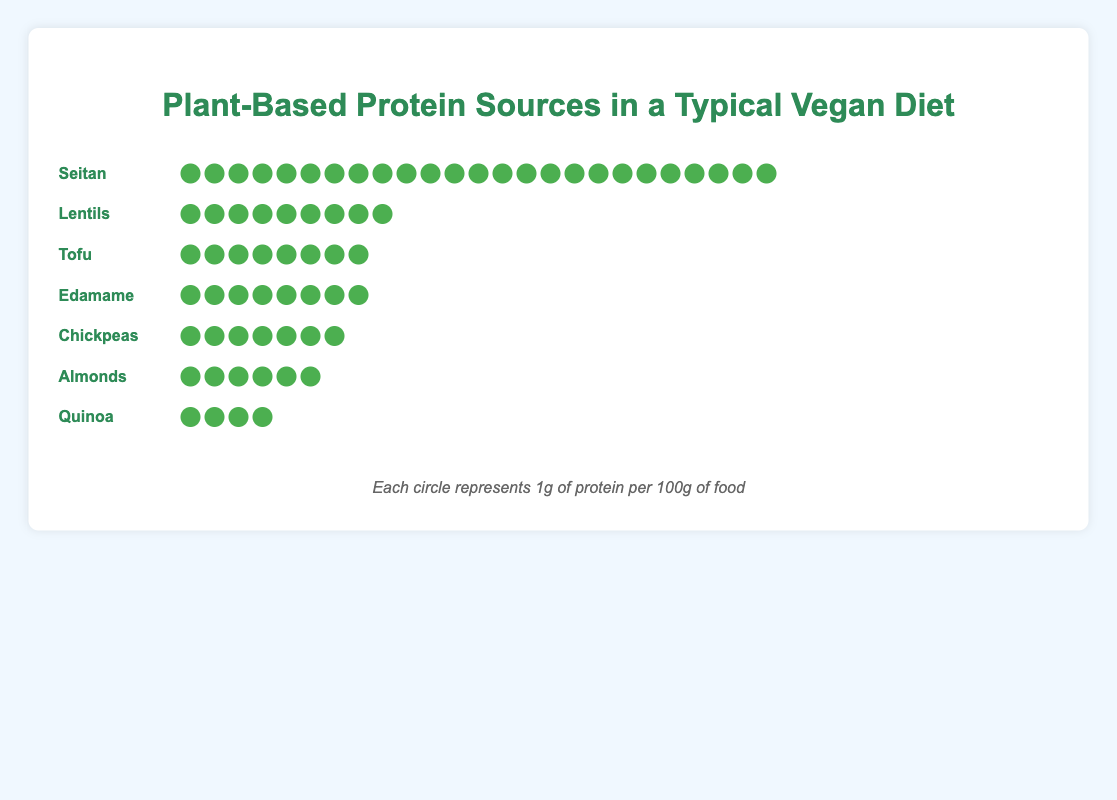Which plant-based protein source has the highest protein content? The isotype plot shows that Seitan has the highest number of protein icons (25) compared to the other protein sources.
Answer: Seitan How many grams of protein does Tofu have per 100g? The isotype plot indicates that each icon represents 1g of protein per 100g. For Tofu, there are 8 icons, which means Tofu has 8 grams of protein per 100g.
Answer: 8g Which protein sources have the same protein content? By counting the number of icons, we can see that Tofu and Edamame each have 8 icons indicating they both contain 8 grams of protein per 100g.
Answer: Tofu and Edamame How much more protein does Chickpeas contain compared to Quinoa per 100g? Chickpeas are represented with 7 icons and Quinoa with 4 icons. The difference is \(7 - 4 = 3\) grams of protein per 100g.
Answer: 3g What is the total protein content from 100g each of Lentils, Tofu, and Quinoa combined? Lentils have 9g, Tofu has 8g, and Quinoa has 4g of protein. Adding these together gives \(9 + 8 + 4 = 21\) grams of protein.
Answer: 21g Which protein source has the least protein content? The isotype plot indicates that Quinoa, with 4 icons, has the least protein content among the listed protein sources.
Answer: Quinoa Which of the protein sources has double the protein content of Almonds? Almonds have 6g of protein per 100g (6 icons). Lentils, with 9g, do not fit. The closest match is Tofu and Edamame, each with 8g, but Seitan surpasses by far. None match exactly double, but Seitan has considerably higher.
Answer: None exactly double, Seitan surpasses by far What is the average protein content per 100g for all seven protein sources? Summing the protein content: Seitan (25), Lentils (9), Tofu (8), Edamame (8), Chickpeas (7), Almonds (6), Quinoa (4). Total protein = \(25 + 9 + 8 + 8 + 7 + 6 + 4 = 67\). Average = \(67 / 7 \approx 9.57\) grams.
Answer: ~9.57g 